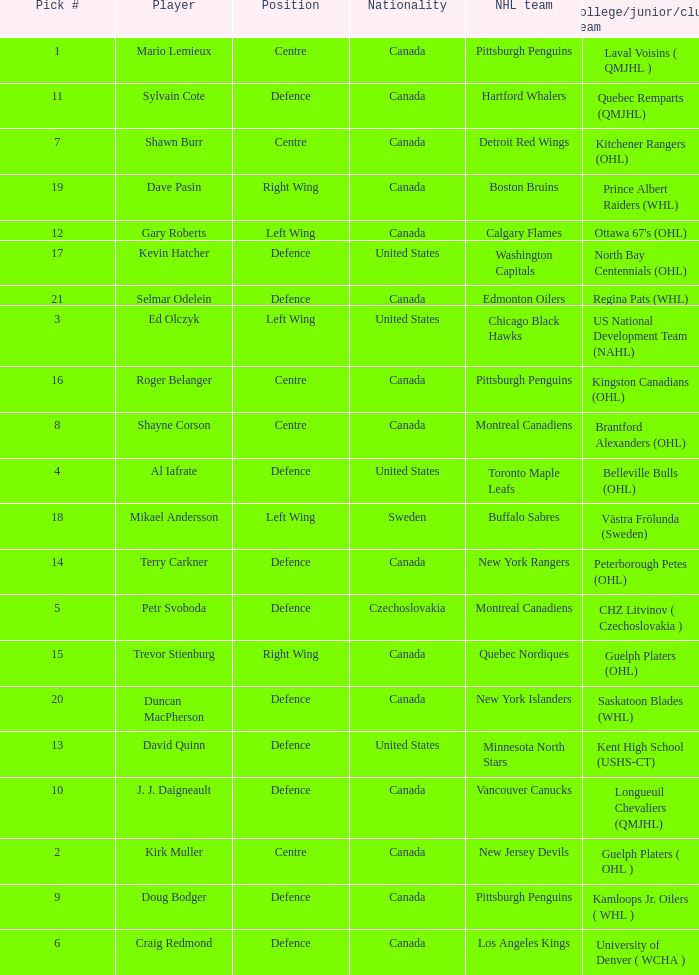What nationality is the draft pick player going to Minnesota North Stars? United States. 